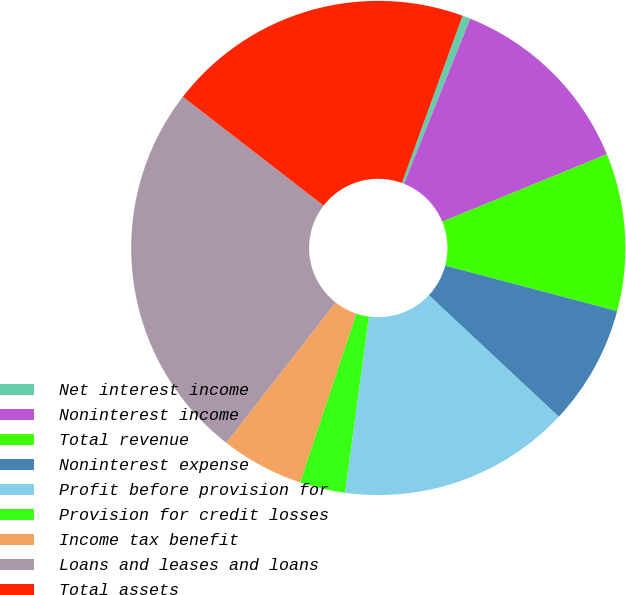Convert chart. <chart><loc_0><loc_0><loc_500><loc_500><pie_chart><fcel>Net interest income<fcel>Noninterest income<fcel>Total revenue<fcel>Noninterest expense<fcel>Profit before provision for<fcel>Provision for credit losses<fcel>Income tax benefit<fcel>Loans and leases and loans<fcel>Total assets<nl><fcel>0.53%<fcel>12.74%<fcel>10.3%<fcel>7.86%<fcel>15.18%<fcel>2.98%<fcel>5.42%<fcel>24.94%<fcel>20.06%<nl></chart> 